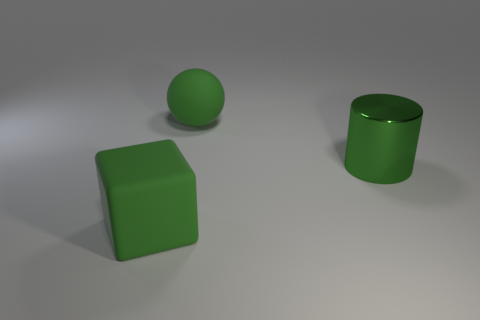Is there anything else that has the same material as the cylinder?
Provide a short and direct response. No. Are there any other things that are the same shape as the green metallic object?
Give a very brief answer. No. The matte ball has what size?
Keep it short and to the point. Large. Are there fewer big green spheres that are behind the big green shiny thing than rubber objects?
Give a very brief answer. Yes. Does the green rubber sphere have the same size as the metal object?
Your response must be concise. Yes. Are there any other things that have the same size as the green cube?
Provide a short and direct response. Yes. What is the color of the block that is the same material as the green sphere?
Ensure brevity in your answer.  Green. Is the number of big metal things that are to the left of the big rubber ball less than the number of rubber spheres in front of the metal object?
Your answer should be very brief. No. How many blocks are the same color as the large metal cylinder?
Provide a succinct answer. 1. There is a large block that is the same color as the metal cylinder; what material is it?
Offer a terse response. Rubber. 